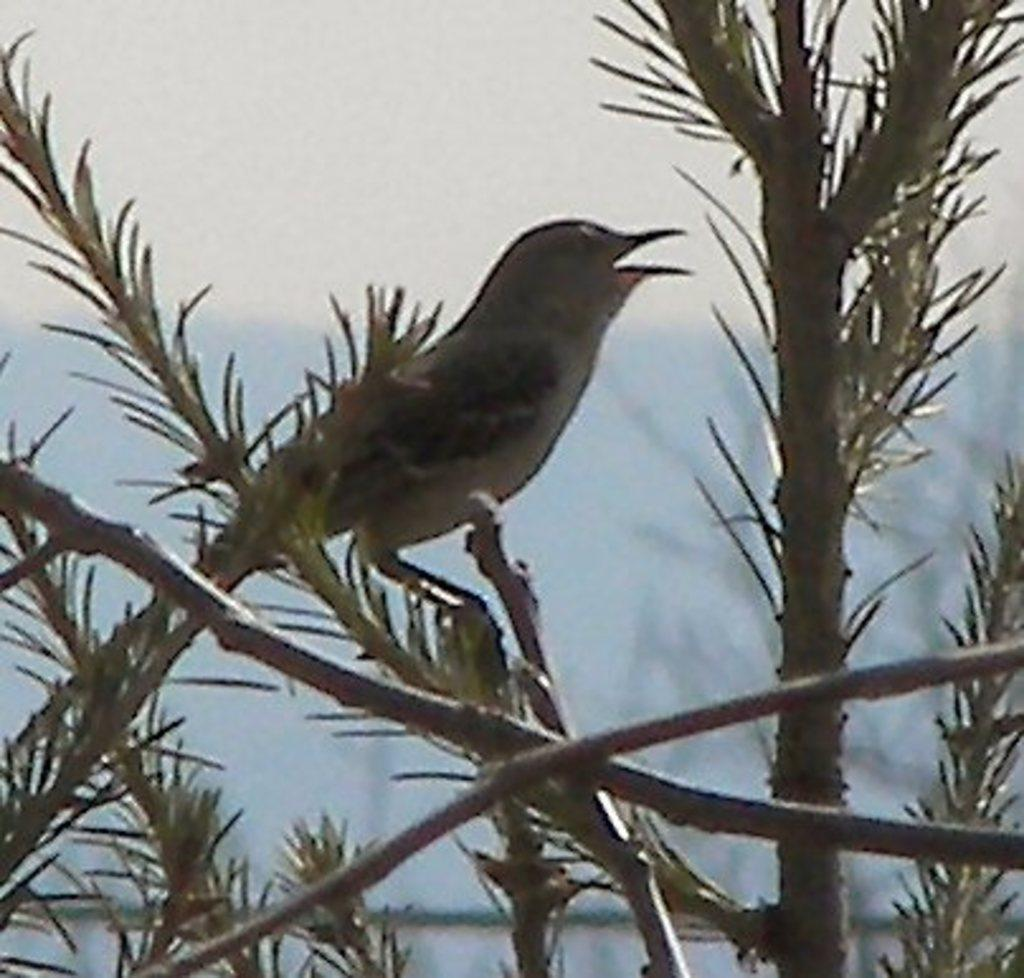What type of animal is in the image? There is a bird in the image. Where is the bird located in the image? The bird is standing on a branch. What is the branch a part of? The branch is part of a tree. Is the bird in jail in the image? There is no indication of a jail or any confinement in the image; the bird is standing on a branch of a tree. 